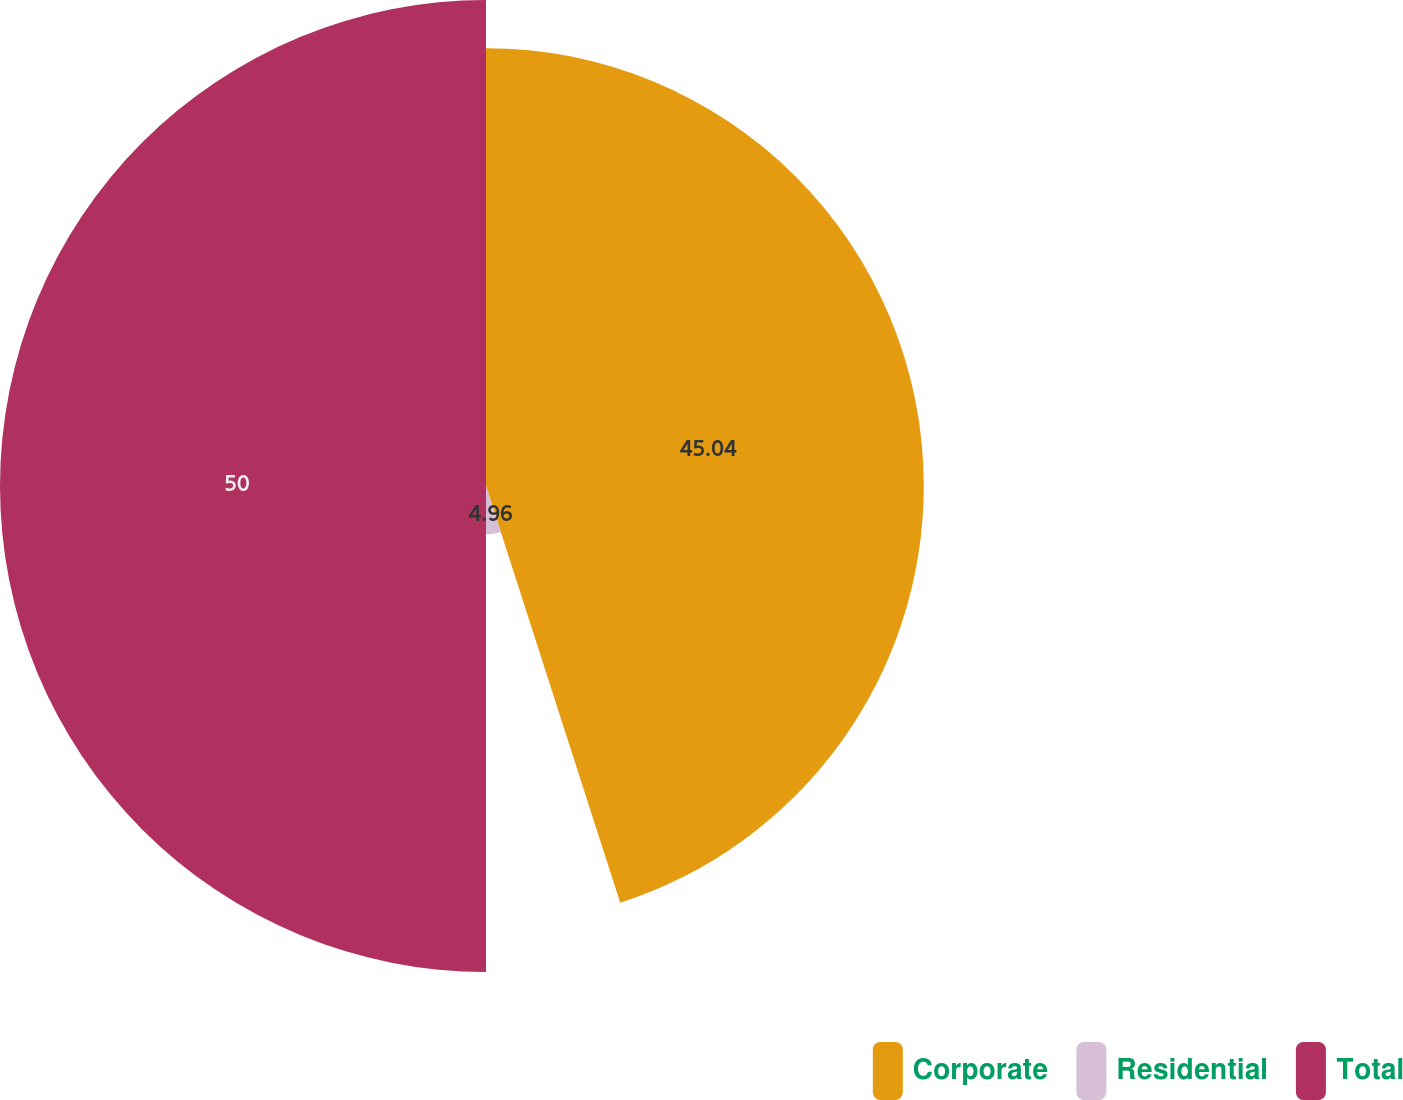Convert chart. <chart><loc_0><loc_0><loc_500><loc_500><pie_chart><fcel>Corporate<fcel>Residential<fcel>Total<nl><fcel>45.04%<fcel>4.96%<fcel>50.0%<nl></chart> 